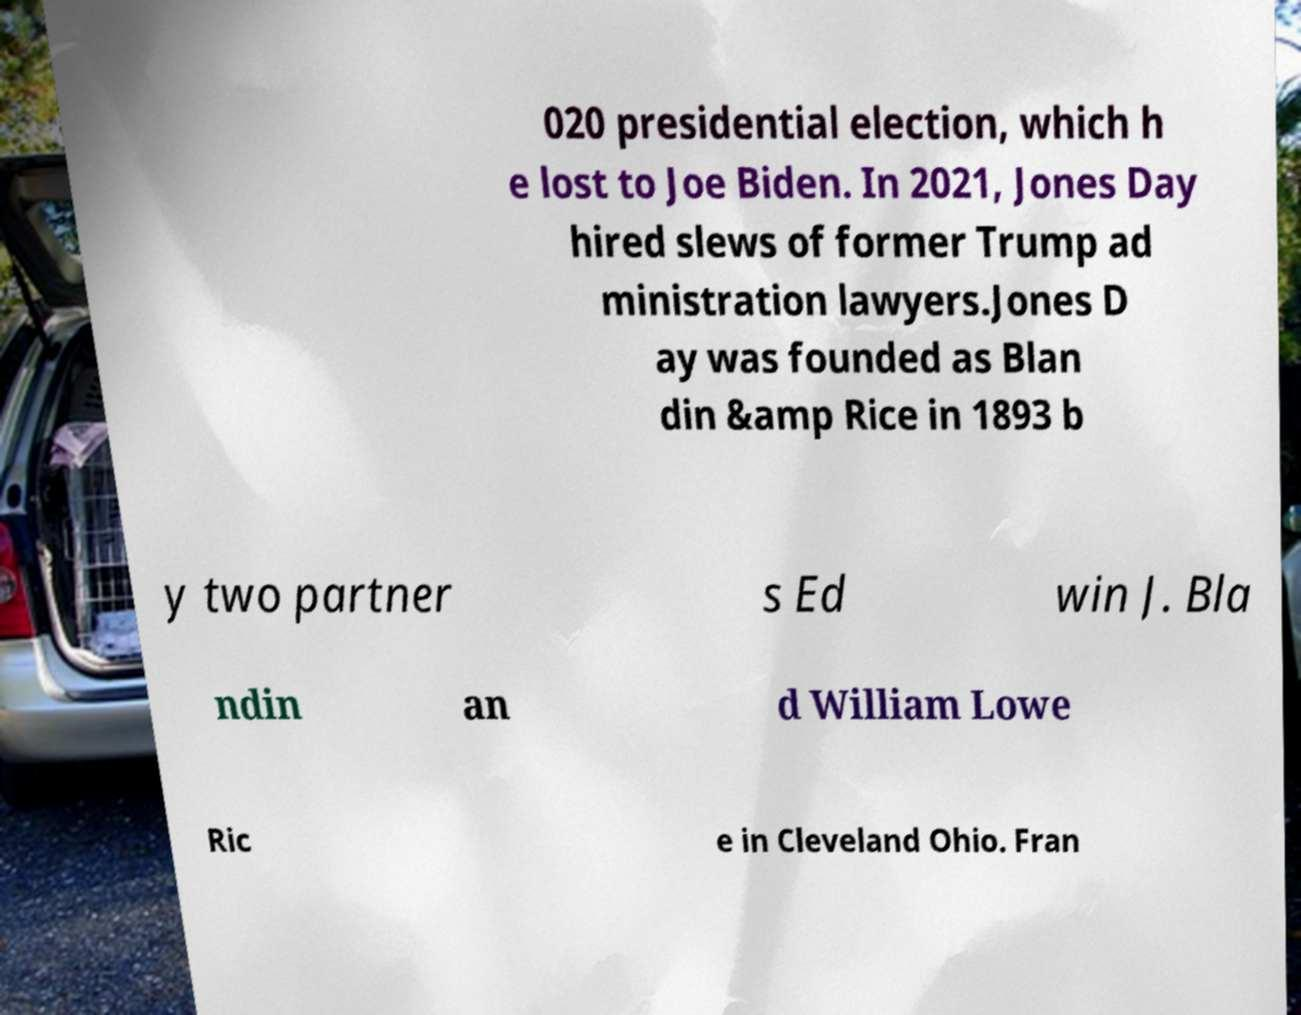I need the written content from this picture converted into text. Can you do that? 020 presidential election, which h e lost to Joe Biden. In 2021, Jones Day hired slews of former Trump ad ministration lawyers.Jones D ay was founded as Blan din &amp Rice in 1893 b y two partner s Ed win J. Bla ndin an d William Lowe Ric e in Cleveland Ohio. Fran 